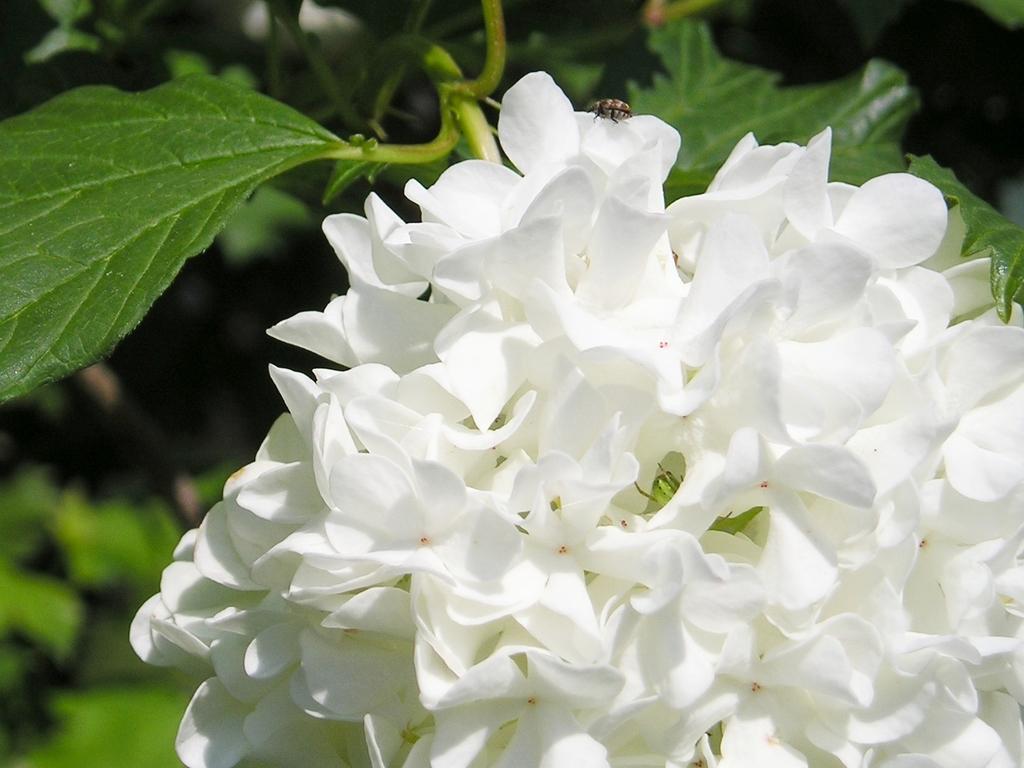Please provide a concise description of this image. In this image there are some flowers at middle of this image is in white color. and there are some leaves in the background and there is one insect at top of this image. 